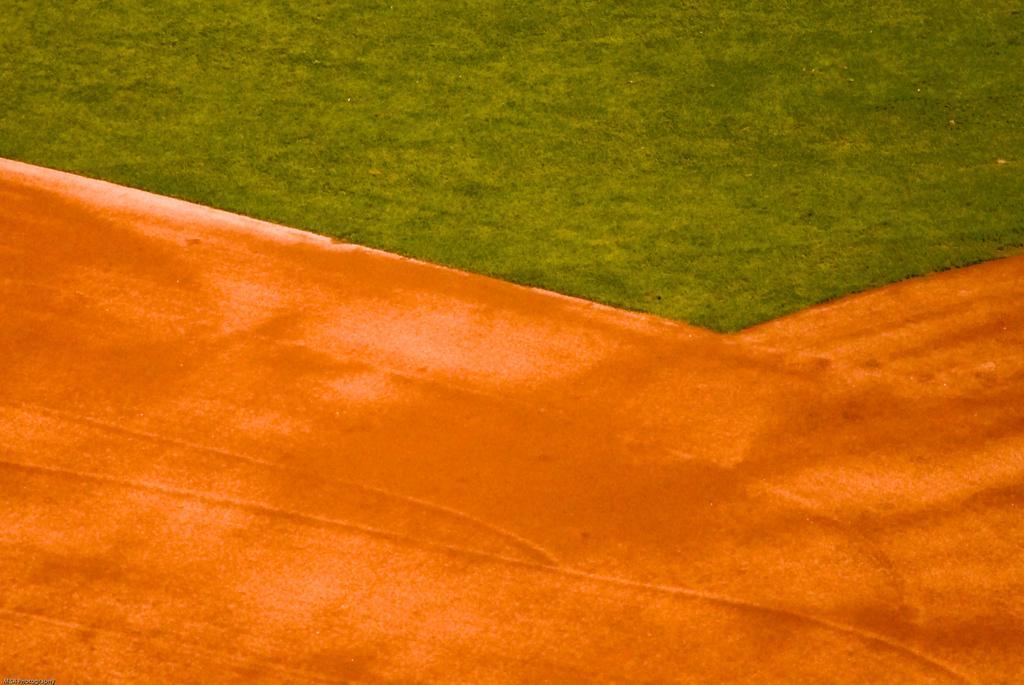Could you give a brief overview of what you see in this image? In this picture we can see grass, it looks like a ground. 